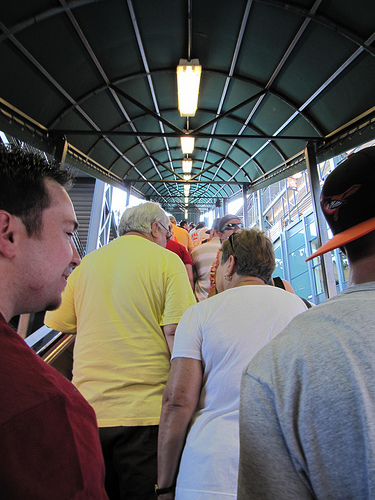<image>
Is there a woman to the left of the man? No. The woman is not to the left of the man. From this viewpoint, they have a different horizontal relationship. 